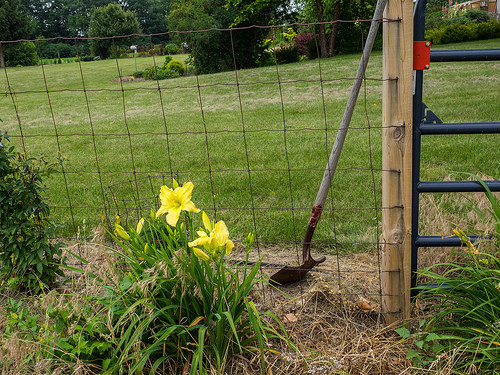<image>
Is there a gate behind the flower? Yes. From this viewpoint, the gate is positioned behind the flower, with the flower partially or fully occluding the gate. Is there a plant behind the fence? No. The plant is not behind the fence. From this viewpoint, the plant appears to be positioned elsewhere in the scene. 